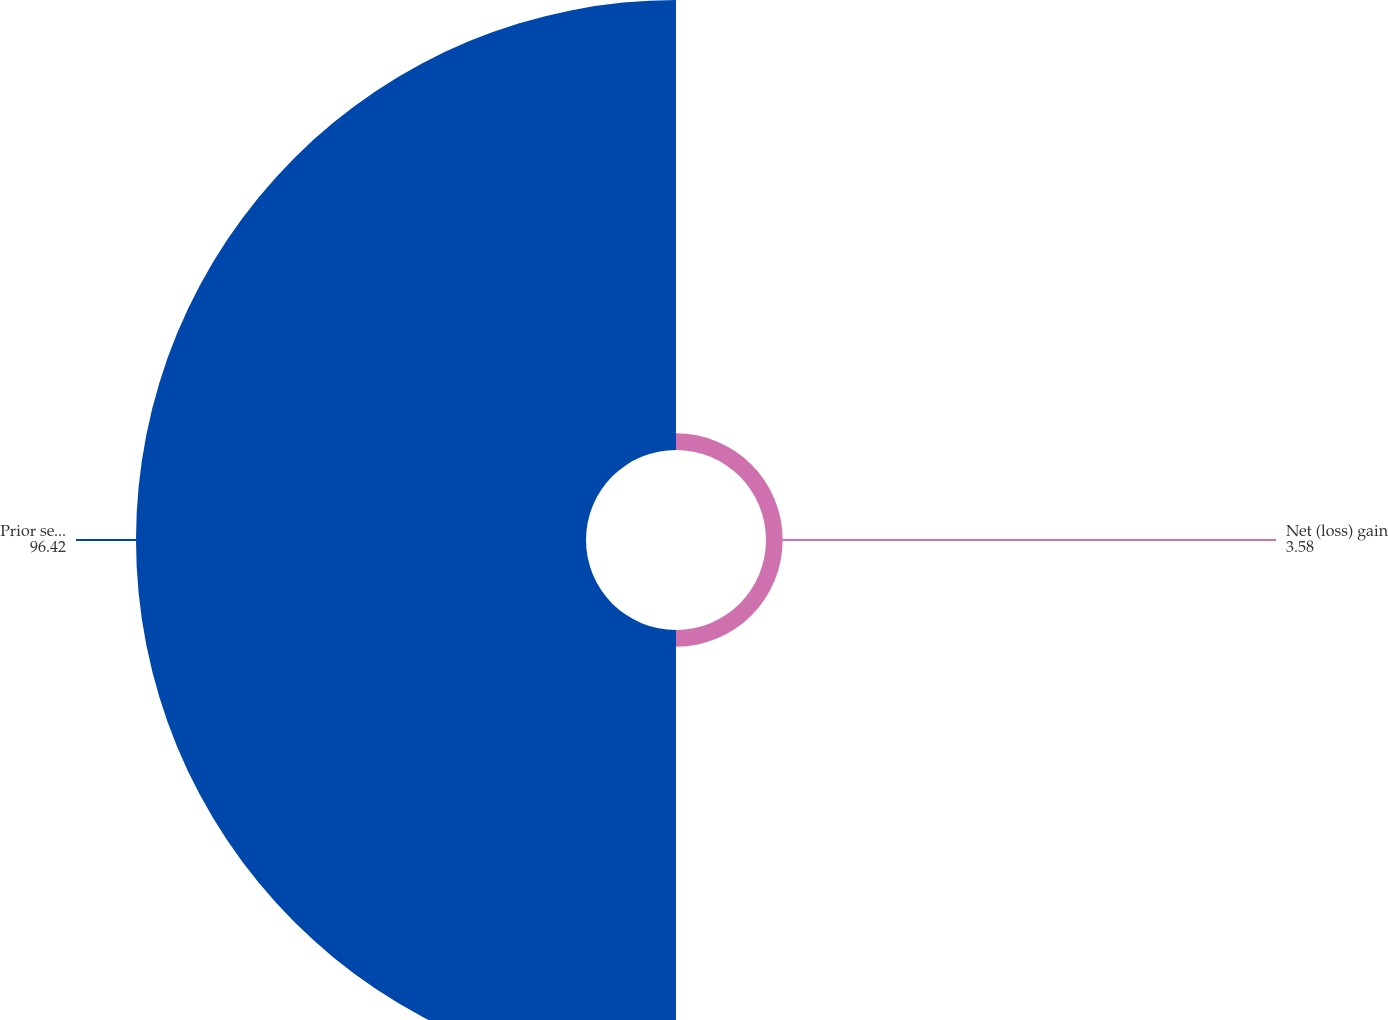<chart> <loc_0><loc_0><loc_500><loc_500><pie_chart><fcel>Net (loss) gain<fcel>Prior service (cost) credit<nl><fcel>3.58%<fcel>96.42%<nl></chart> 